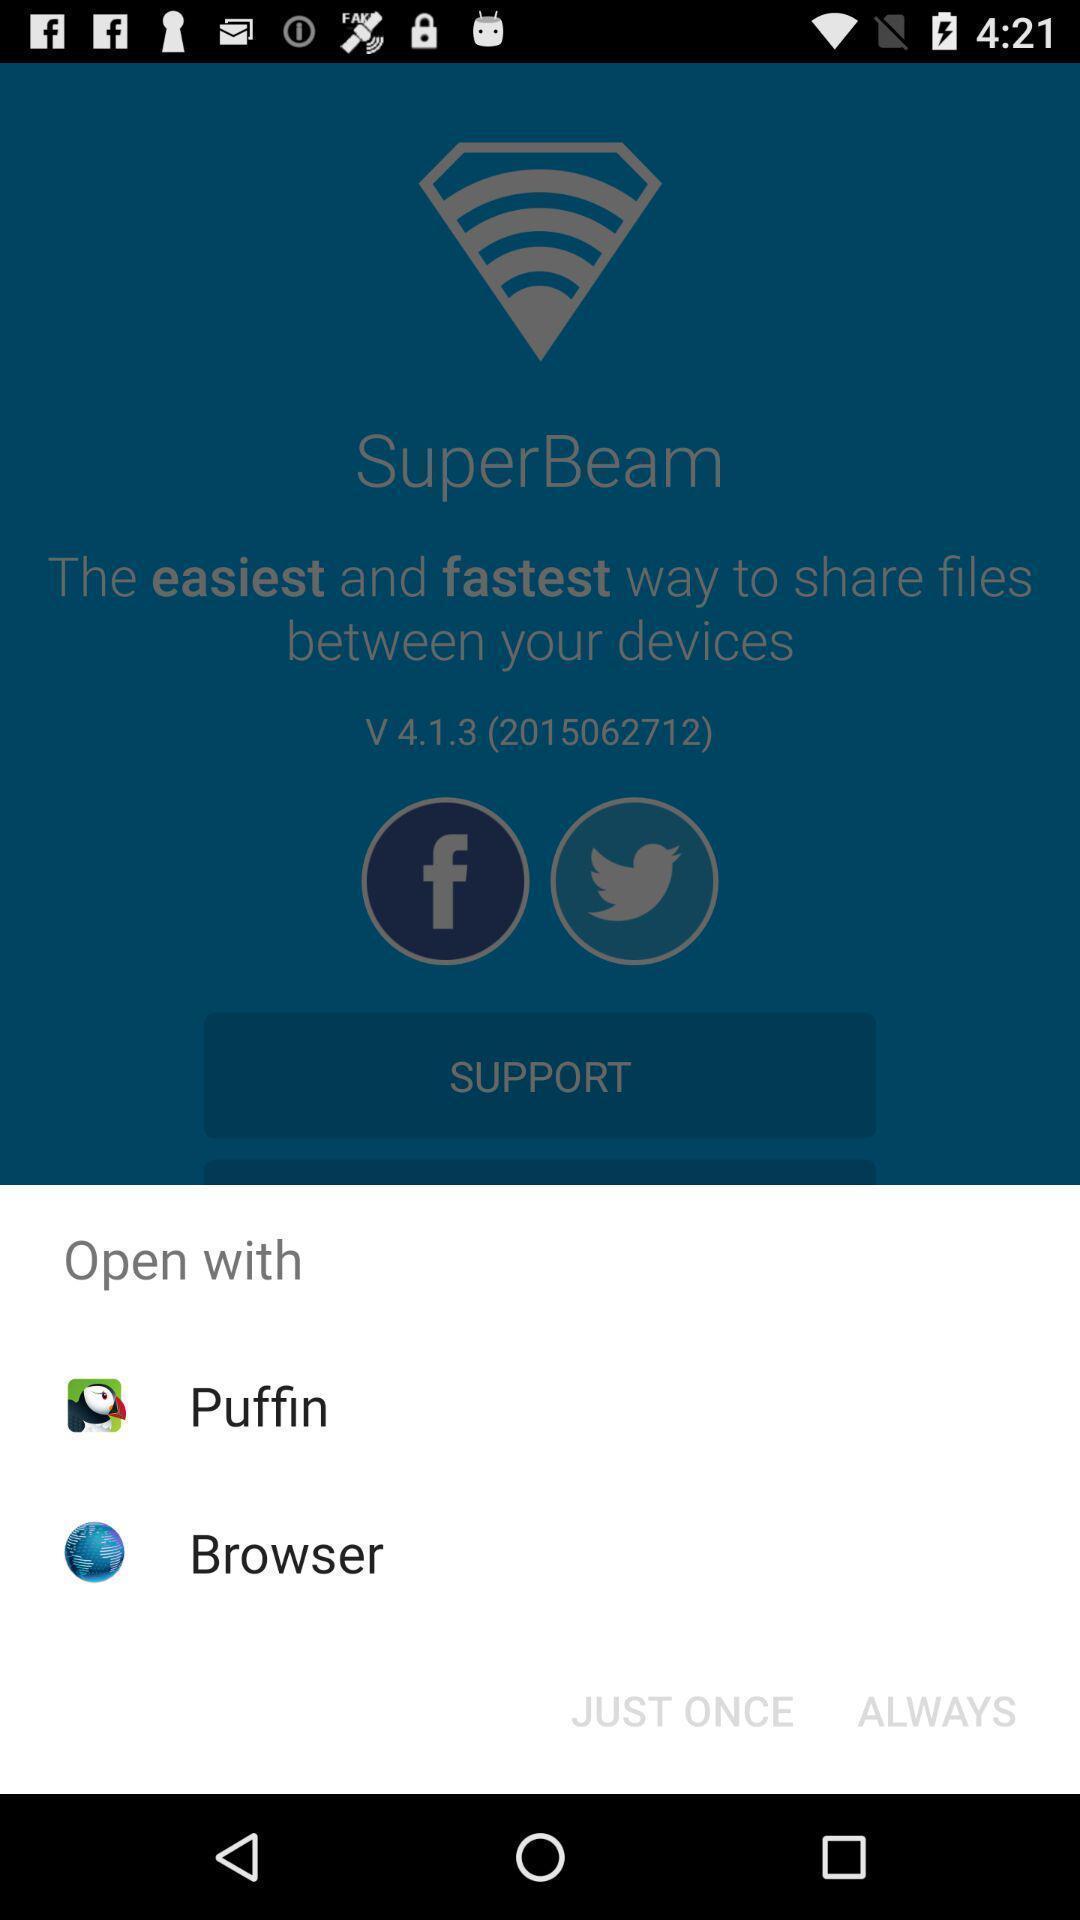Describe the visual elements of this screenshot. Popup displaying multiple options to open an app with. 